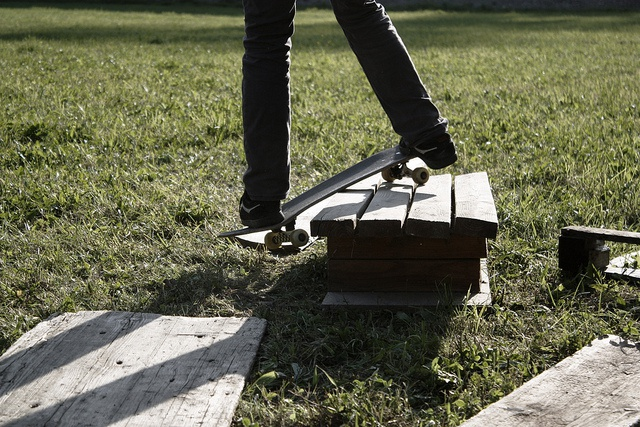Describe the objects in this image and their specific colors. I can see people in black, gray, olive, and lightgray tones and skateboard in black, gray, white, and darkgray tones in this image. 